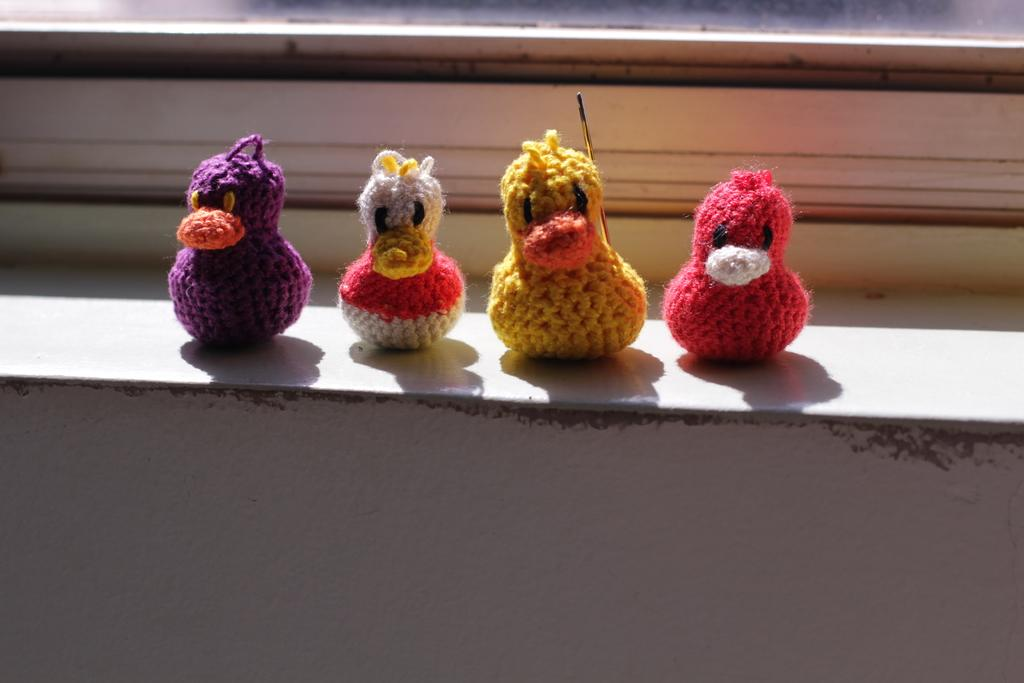How many toys are hanging on the wall in the image? There are four toys on the wall in the image. Can you describe the objects visible in the background of the image? Unfortunately, the provided facts do not give any information about the objects in the background. Is there a quiver of arrows hanging on the wall next to the toys? No, there is no quiver of arrows visible in the image. 